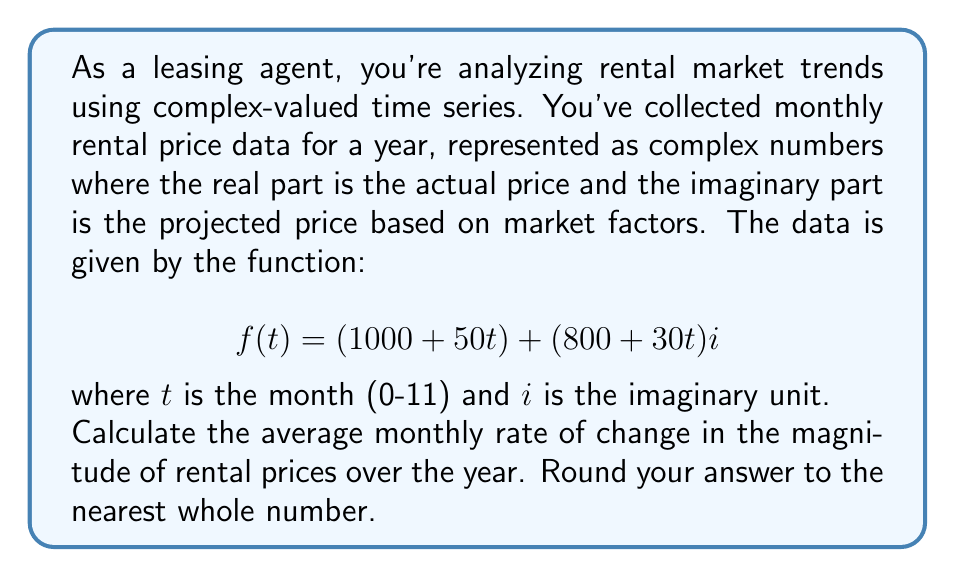Can you answer this question? To solve this problem, we'll follow these steps:

1) The magnitude of a complex number $z = a + bi$ is given by $|z| = \sqrt{a^2 + b^2}$.

2) For our function $f(t) = (1000 + 50t) + (800 + 30t)i$, the magnitude is:

   $$|f(t)| = \sqrt{(1000 + 50t)^2 + (800 + 30t)^2}$$

3) To find the rate of change, we need to calculate this at $t=0$ and $t=11$:

   At $t=0$: $|f(0)| = \sqrt{1000^2 + 800^2} = \sqrt{1,640,000} \approx 1280.62$
   
   At $t=11$: $|f(11)| = \sqrt{(1550)^2 + (1130)^2} = \sqrt{3,624,100} \approx 1903.71$

4) The total change over 11 months is approximately 1903.71 - 1280.62 = 623.09

5) The average monthly rate of change is 623.09 / 11 ≈ 56.64

6) Rounding to the nearest whole number gives 57.
Answer: 57 